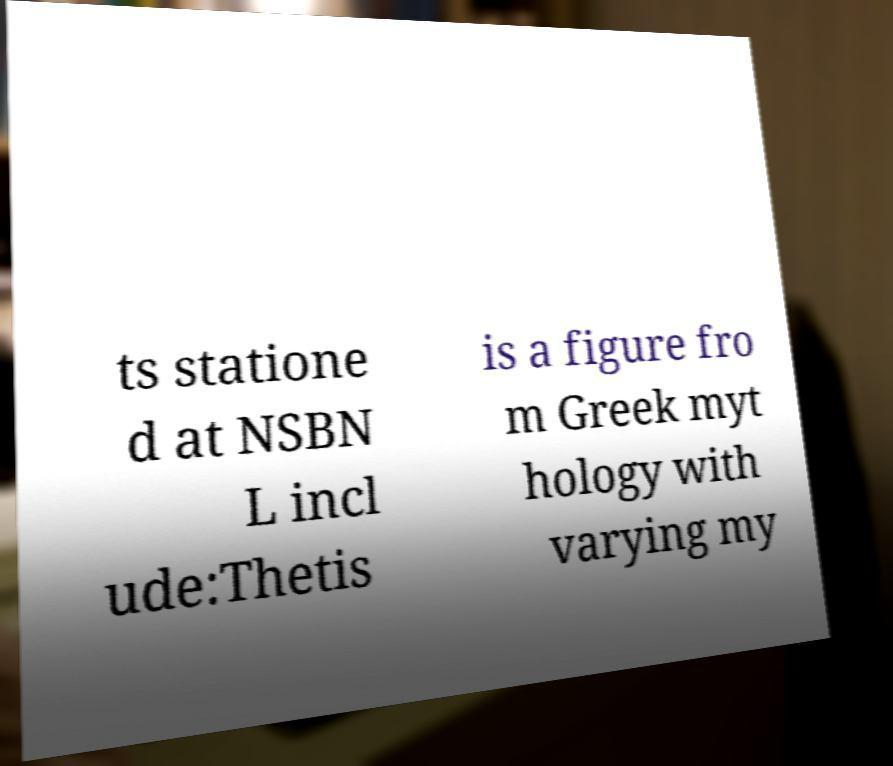I need the written content from this picture converted into text. Can you do that? ts statione d at NSBN L incl ude:Thetis is a figure fro m Greek myt hology with varying my 